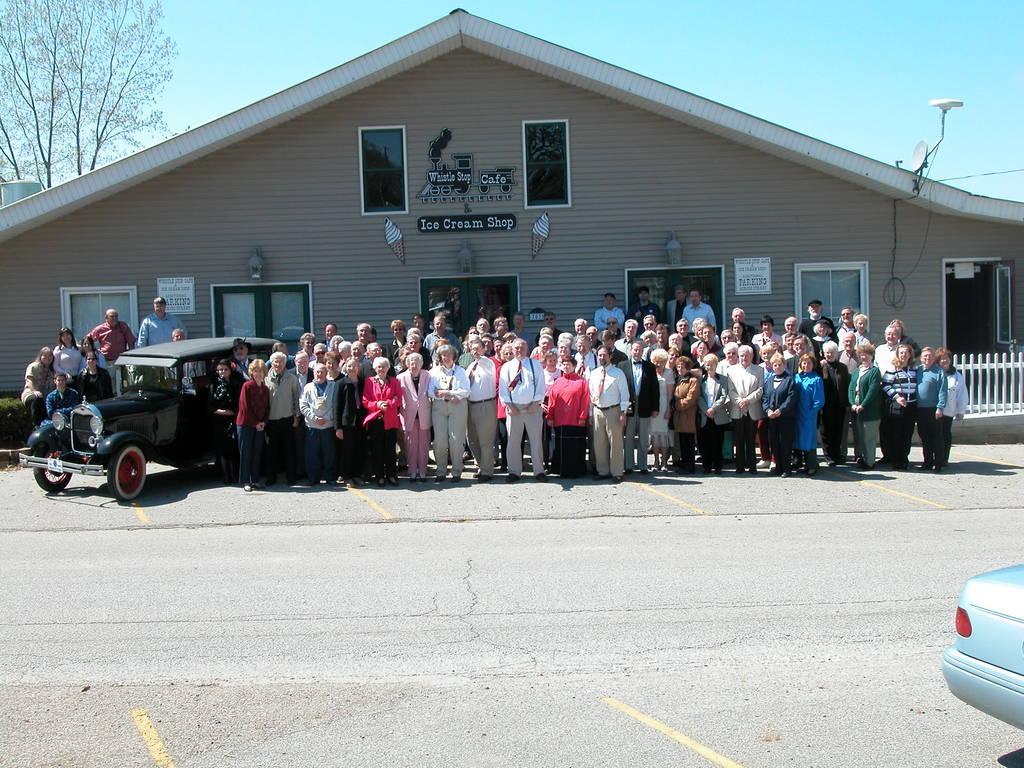Please provide a concise description of this image. In this image I can see a road, few vehicles and in the background I can see number of people are standing. I can also see a building, number of boards and on these boards I can see something is written. I can also see a tree and the sky in the background. 